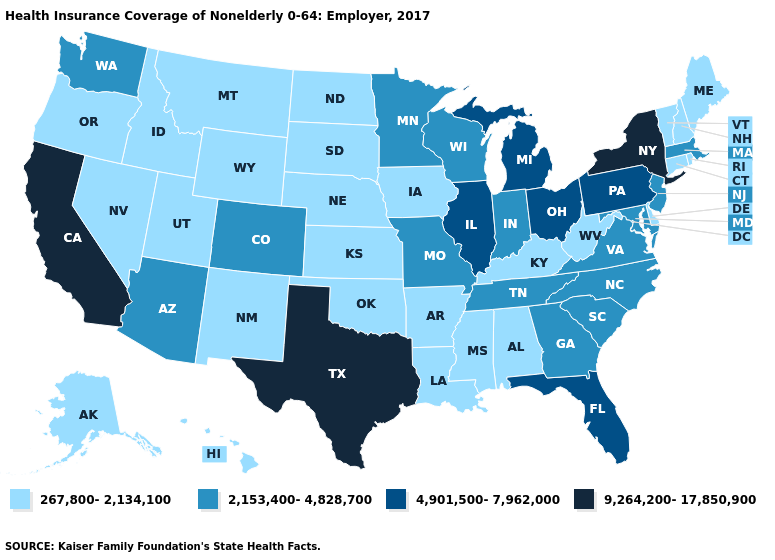Name the states that have a value in the range 267,800-2,134,100?
Be succinct. Alabama, Alaska, Arkansas, Connecticut, Delaware, Hawaii, Idaho, Iowa, Kansas, Kentucky, Louisiana, Maine, Mississippi, Montana, Nebraska, Nevada, New Hampshire, New Mexico, North Dakota, Oklahoma, Oregon, Rhode Island, South Dakota, Utah, Vermont, West Virginia, Wyoming. What is the value of New Mexico?
Give a very brief answer. 267,800-2,134,100. What is the value of Iowa?
Write a very short answer. 267,800-2,134,100. What is the value of Hawaii?
Concise answer only. 267,800-2,134,100. Name the states that have a value in the range 4,901,500-7,962,000?
Write a very short answer. Florida, Illinois, Michigan, Ohio, Pennsylvania. What is the value of Connecticut?
Quick response, please. 267,800-2,134,100. What is the highest value in states that border Iowa?
Short answer required. 4,901,500-7,962,000. What is the value of Delaware?
Give a very brief answer. 267,800-2,134,100. How many symbols are there in the legend?
Give a very brief answer. 4. Which states hav the highest value in the South?
Keep it brief. Texas. Name the states that have a value in the range 9,264,200-17,850,900?
Concise answer only. California, New York, Texas. Which states have the highest value in the USA?
Give a very brief answer. California, New York, Texas. Among the states that border Kansas , does Colorado have the highest value?
Be succinct. Yes. What is the highest value in the MidWest ?
Quick response, please. 4,901,500-7,962,000. What is the highest value in the USA?
Quick response, please. 9,264,200-17,850,900. 